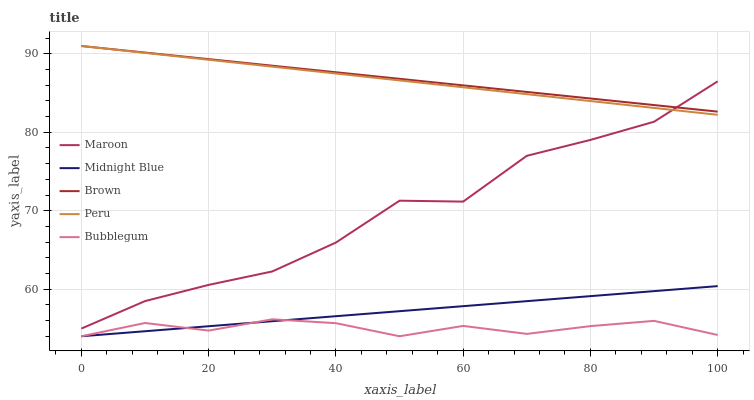Does Bubblegum have the minimum area under the curve?
Answer yes or no. Yes. Does Brown have the maximum area under the curve?
Answer yes or no. Yes. Does Brown have the minimum area under the curve?
Answer yes or no. No. Does Bubblegum have the maximum area under the curve?
Answer yes or no. No. Is Midnight Blue the smoothest?
Answer yes or no. Yes. Is Maroon the roughest?
Answer yes or no. Yes. Is Brown the smoothest?
Answer yes or no. No. Is Brown the roughest?
Answer yes or no. No. Does Bubblegum have the lowest value?
Answer yes or no. Yes. Does Brown have the lowest value?
Answer yes or no. No. Does Brown have the highest value?
Answer yes or no. Yes. Does Bubblegum have the highest value?
Answer yes or no. No. Is Midnight Blue less than Maroon?
Answer yes or no. Yes. Is Maroon greater than Bubblegum?
Answer yes or no. Yes. Does Peru intersect Brown?
Answer yes or no. Yes. Is Peru less than Brown?
Answer yes or no. No. Is Peru greater than Brown?
Answer yes or no. No. Does Midnight Blue intersect Maroon?
Answer yes or no. No. 